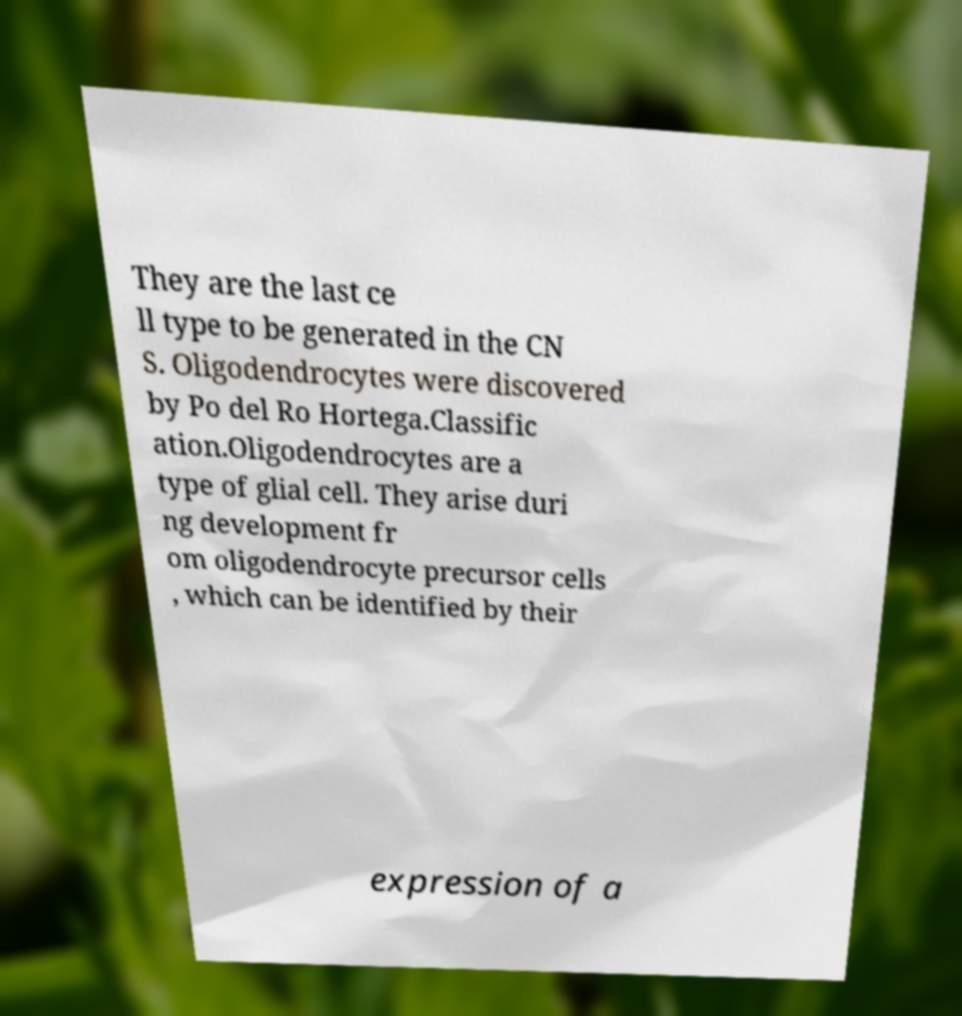There's text embedded in this image that I need extracted. Can you transcribe it verbatim? They are the last ce ll type to be generated in the CN S. Oligodendrocytes were discovered by Po del Ro Hortega.Classific ation.Oligodendrocytes are a type of glial cell. They arise duri ng development fr om oligodendrocyte precursor cells , which can be identified by their expression of a 